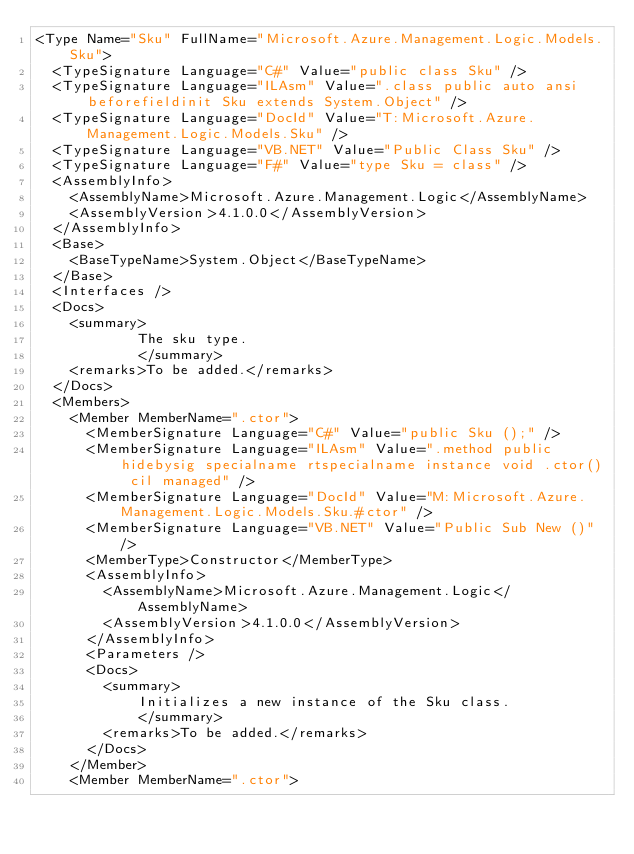Convert code to text. <code><loc_0><loc_0><loc_500><loc_500><_XML_><Type Name="Sku" FullName="Microsoft.Azure.Management.Logic.Models.Sku">
  <TypeSignature Language="C#" Value="public class Sku" />
  <TypeSignature Language="ILAsm" Value=".class public auto ansi beforefieldinit Sku extends System.Object" />
  <TypeSignature Language="DocId" Value="T:Microsoft.Azure.Management.Logic.Models.Sku" />
  <TypeSignature Language="VB.NET" Value="Public Class Sku" />
  <TypeSignature Language="F#" Value="type Sku = class" />
  <AssemblyInfo>
    <AssemblyName>Microsoft.Azure.Management.Logic</AssemblyName>
    <AssemblyVersion>4.1.0.0</AssemblyVersion>
  </AssemblyInfo>
  <Base>
    <BaseTypeName>System.Object</BaseTypeName>
  </Base>
  <Interfaces />
  <Docs>
    <summary>
            The sku type.
            </summary>
    <remarks>To be added.</remarks>
  </Docs>
  <Members>
    <Member MemberName=".ctor">
      <MemberSignature Language="C#" Value="public Sku ();" />
      <MemberSignature Language="ILAsm" Value=".method public hidebysig specialname rtspecialname instance void .ctor() cil managed" />
      <MemberSignature Language="DocId" Value="M:Microsoft.Azure.Management.Logic.Models.Sku.#ctor" />
      <MemberSignature Language="VB.NET" Value="Public Sub New ()" />
      <MemberType>Constructor</MemberType>
      <AssemblyInfo>
        <AssemblyName>Microsoft.Azure.Management.Logic</AssemblyName>
        <AssemblyVersion>4.1.0.0</AssemblyVersion>
      </AssemblyInfo>
      <Parameters />
      <Docs>
        <summary>
            Initializes a new instance of the Sku class.
            </summary>
        <remarks>To be added.</remarks>
      </Docs>
    </Member>
    <Member MemberName=".ctor"></code> 